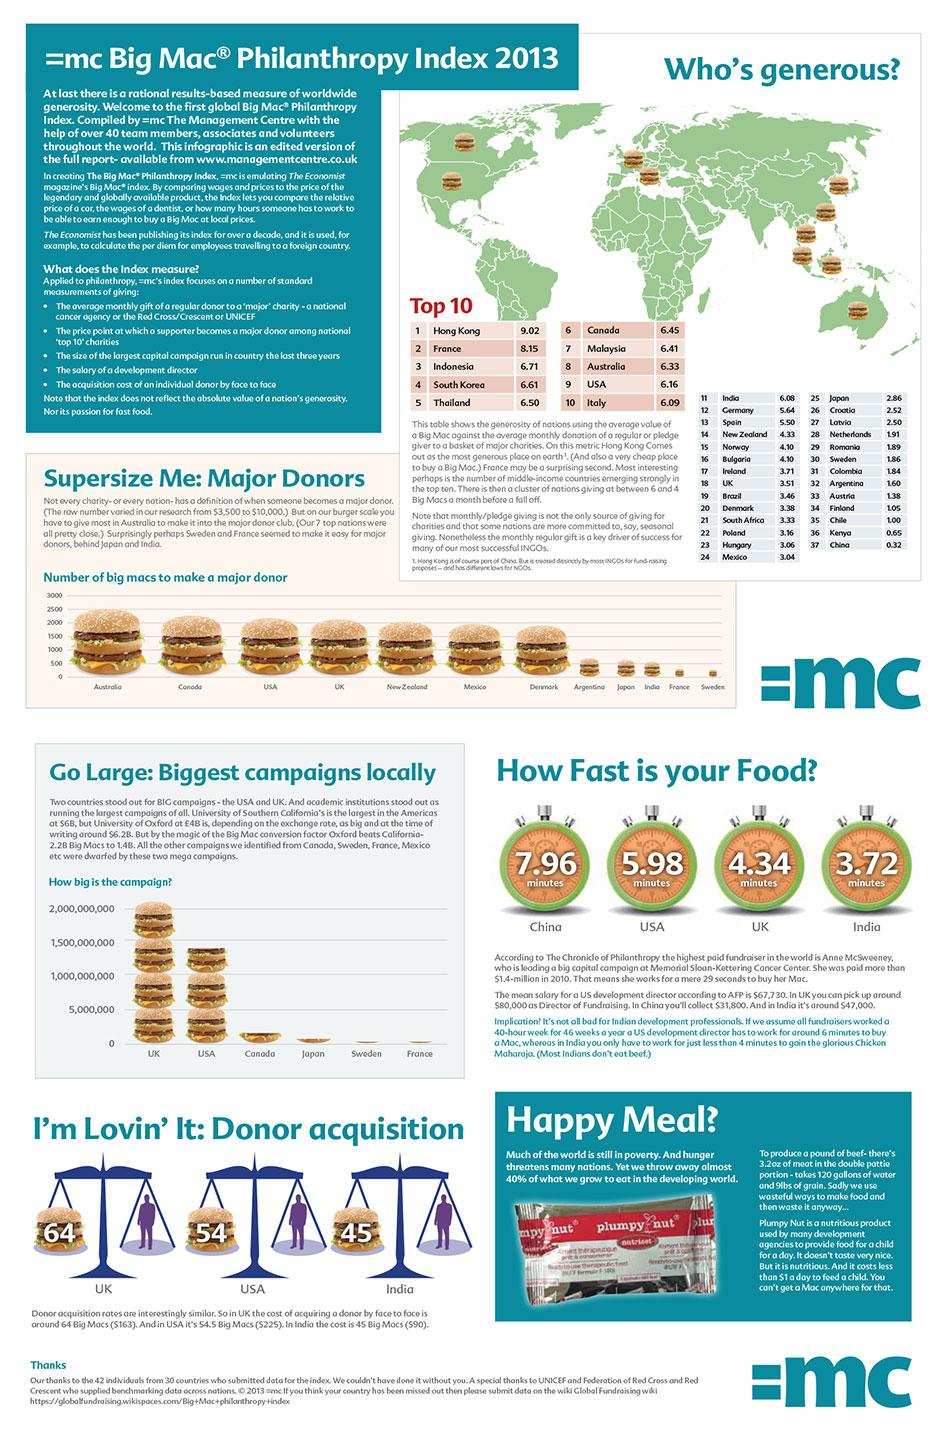Outline some significant characteristics in this image. Two countries, Mexico and Denmark, require fewer than 2000 but more than 1000 Big Macs to be designated as a major donor. In the generosity ranking, only two nations have given between 6 and 5 Big Macs. According to estimates, it would take 2250 Big Macs to make a major donor in Canada. There are approximately 10 burger images on the world map. I have learned that the Happy Meal provided to poor children is called Plumpy Nut. 